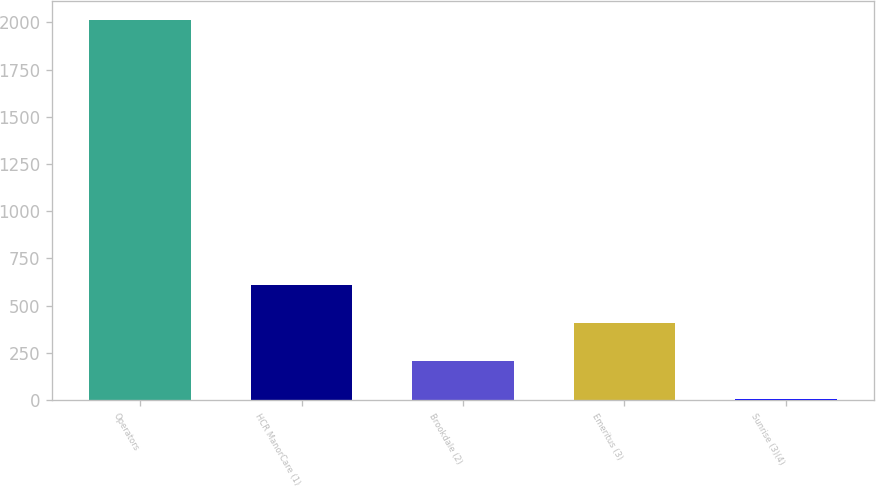Convert chart. <chart><loc_0><loc_0><loc_500><loc_500><bar_chart><fcel>Operators<fcel>HCR ManorCare (1)<fcel>Brookdale (2)<fcel>Emeritus (3)<fcel>Sunrise (3)(4)<nl><fcel>2011<fcel>607.5<fcel>206.5<fcel>407<fcel>6<nl></chart> 